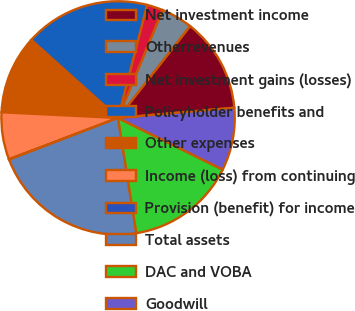Convert chart. <chart><loc_0><loc_0><loc_500><loc_500><pie_chart><fcel>Net investment income<fcel>Otherrevenues<fcel>Net investment gains (losses)<fcel>Policyholder benefits and<fcel>Other expenses<fcel>Income (loss) from continuing<fcel>Provision (benefit) for income<fcel>Total assets<fcel>DAC and VOBA<fcel>Goodwill<nl><fcel>13.03%<fcel>4.37%<fcel>2.21%<fcel>17.36%<fcel>10.87%<fcel>6.54%<fcel>0.05%<fcel>21.69%<fcel>15.19%<fcel>8.7%<nl></chart> 